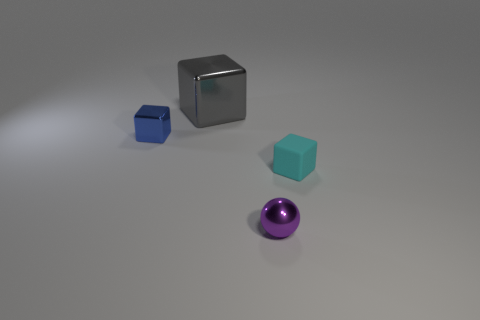What might be the purpose of arranging these objects this way? The arrangement might be intended to showcase a contrast in colors and sizes, which could be a part of a study in visual perception or for artistic purposes. The different shapes and hues create a diverse composition that draws the viewer's attention. 